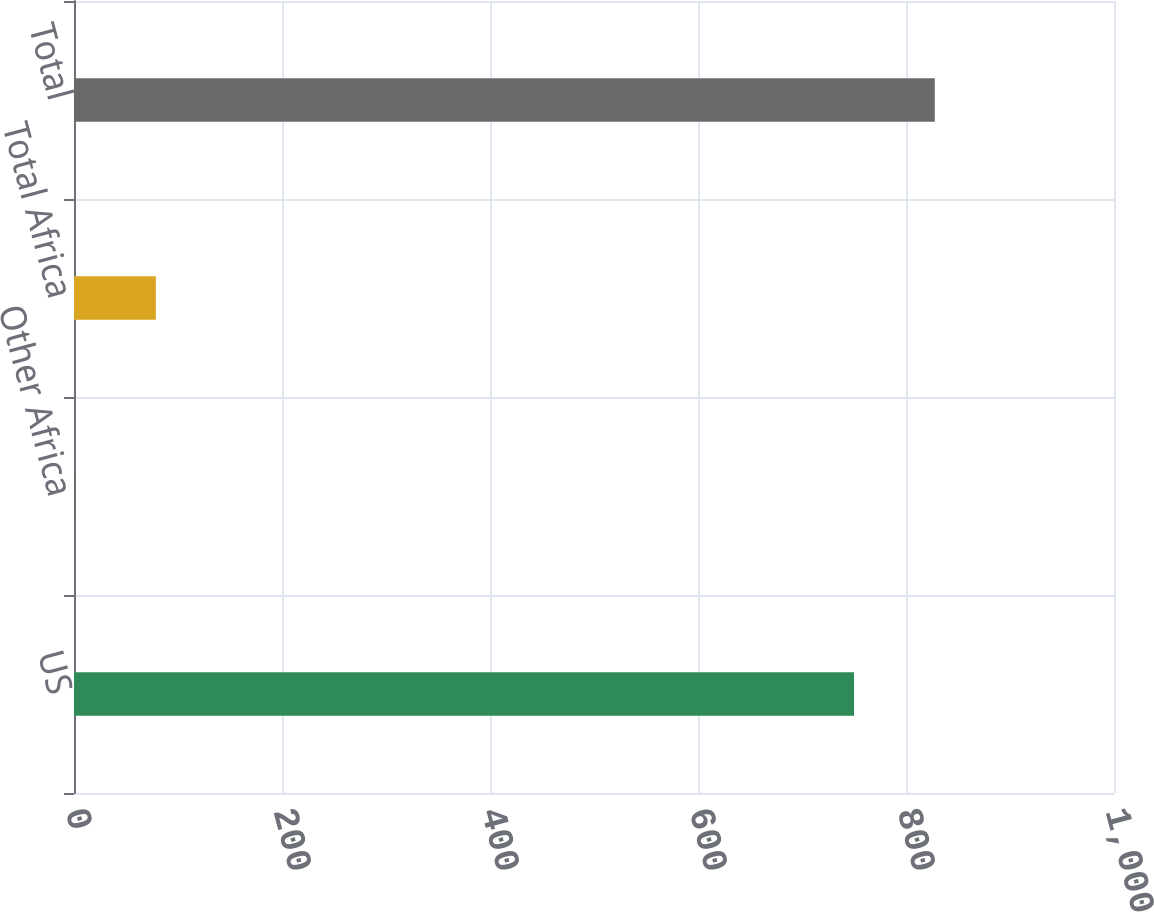Convert chart. <chart><loc_0><loc_0><loc_500><loc_500><bar_chart><fcel>US<fcel>Other Africa<fcel>Total Africa<fcel>Total<nl><fcel>750<fcel>1<fcel>78.7<fcel>827.7<nl></chart> 